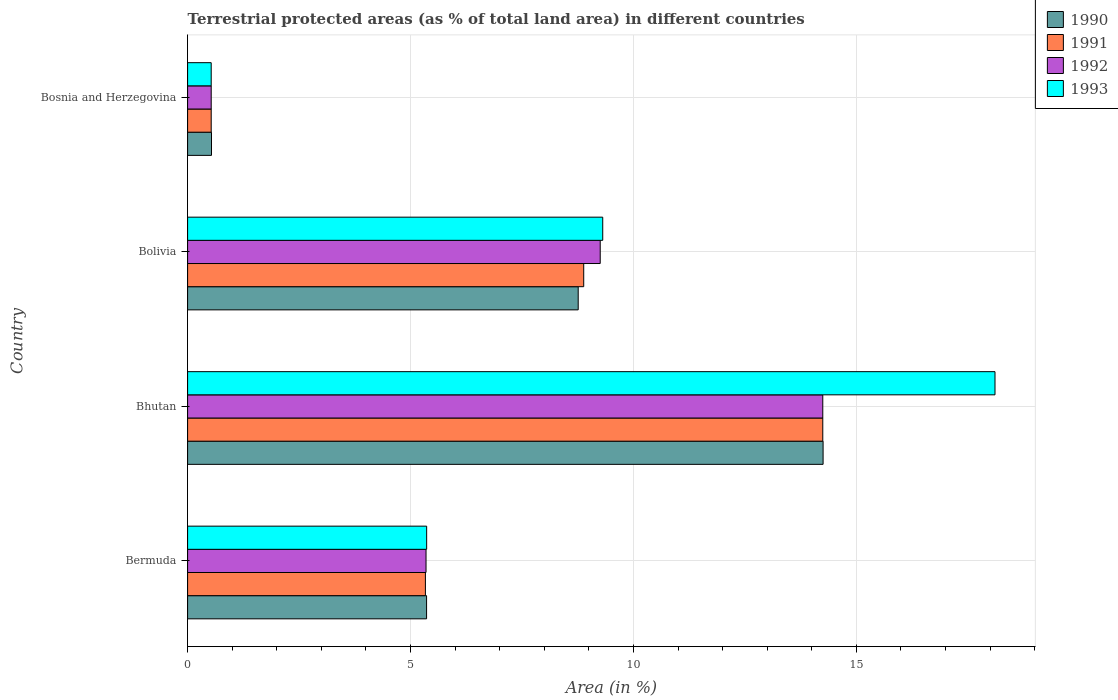How many different coloured bars are there?
Offer a terse response. 4. How many groups of bars are there?
Give a very brief answer. 4. How many bars are there on the 2nd tick from the top?
Offer a very short reply. 4. How many bars are there on the 3rd tick from the bottom?
Provide a succinct answer. 4. What is the label of the 2nd group of bars from the top?
Offer a very short reply. Bolivia. What is the percentage of terrestrial protected land in 1992 in Bhutan?
Ensure brevity in your answer.  14.25. Across all countries, what is the maximum percentage of terrestrial protected land in 1991?
Your answer should be very brief. 14.25. Across all countries, what is the minimum percentage of terrestrial protected land in 1991?
Offer a terse response. 0.53. In which country was the percentage of terrestrial protected land in 1993 maximum?
Make the answer very short. Bhutan. In which country was the percentage of terrestrial protected land in 1991 minimum?
Provide a succinct answer. Bosnia and Herzegovina. What is the total percentage of terrestrial protected land in 1991 in the graph?
Your answer should be compact. 28.99. What is the difference between the percentage of terrestrial protected land in 1991 in Bolivia and that in Bosnia and Herzegovina?
Your answer should be compact. 8.35. What is the difference between the percentage of terrestrial protected land in 1993 in Bolivia and the percentage of terrestrial protected land in 1991 in Bosnia and Herzegovina?
Your response must be concise. 8.78. What is the average percentage of terrestrial protected land in 1993 per country?
Provide a succinct answer. 8.33. What is the difference between the percentage of terrestrial protected land in 1990 and percentage of terrestrial protected land in 1992 in Bhutan?
Ensure brevity in your answer.  0.01. In how many countries, is the percentage of terrestrial protected land in 1992 greater than 2 %?
Your answer should be compact. 3. What is the ratio of the percentage of terrestrial protected land in 1991 in Bermuda to that in Bhutan?
Ensure brevity in your answer.  0.37. What is the difference between the highest and the second highest percentage of terrestrial protected land in 1991?
Give a very brief answer. 5.36. What is the difference between the highest and the lowest percentage of terrestrial protected land in 1990?
Ensure brevity in your answer.  13.72. Is the sum of the percentage of terrestrial protected land in 1991 in Bermuda and Bosnia and Herzegovina greater than the maximum percentage of terrestrial protected land in 1992 across all countries?
Your answer should be compact. No. What does the 2nd bar from the top in Bermuda represents?
Your answer should be compact. 1992. What does the 4th bar from the bottom in Bermuda represents?
Offer a terse response. 1993. Are all the bars in the graph horizontal?
Keep it short and to the point. Yes. How many countries are there in the graph?
Give a very brief answer. 4. What is the difference between two consecutive major ticks on the X-axis?
Provide a short and direct response. 5. Are the values on the major ticks of X-axis written in scientific E-notation?
Provide a succinct answer. No. Does the graph contain grids?
Offer a very short reply. Yes. Where does the legend appear in the graph?
Keep it short and to the point. Top right. How many legend labels are there?
Make the answer very short. 4. How are the legend labels stacked?
Provide a succinct answer. Vertical. What is the title of the graph?
Your answer should be very brief. Terrestrial protected areas (as % of total land area) in different countries. Does "1997" appear as one of the legend labels in the graph?
Provide a short and direct response. No. What is the label or title of the X-axis?
Keep it short and to the point. Area (in %). What is the Area (in %) in 1990 in Bermuda?
Keep it short and to the point. 5.36. What is the Area (in %) in 1991 in Bermuda?
Provide a short and direct response. 5.33. What is the Area (in %) in 1992 in Bermuda?
Keep it short and to the point. 5.35. What is the Area (in %) of 1993 in Bermuda?
Offer a very short reply. 5.36. What is the Area (in %) in 1990 in Bhutan?
Your answer should be very brief. 14.25. What is the Area (in %) of 1991 in Bhutan?
Offer a terse response. 14.25. What is the Area (in %) in 1992 in Bhutan?
Offer a terse response. 14.25. What is the Area (in %) in 1993 in Bhutan?
Offer a very short reply. 18.11. What is the Area (in %) in 1990 in Bolivia?
Your response must be concise. 8.76. What is the Area (in %) of 1991 in Bolivia?
Offer a terse response. 8.88. What is the Area (in %) of 1992 in Bolivia?
Provide a short and direct response. 9.25. What is the Area (in %) in 1993 in Bolivia?
Provide a short and direct response. 9.31. What is the Area (in %) in 1990 in Bosnia and Herzegovina?
Your answer should be very brief. 0.54. What is the Area (in %) in 1991 in Bosnia and Herzegovina?
Your answer should be very brief. 0.53. What is the Area (in %) in 1992 in Bosnia and Herzegovina?
Your response must be concise. 0.53. What is the Area (in %) in 1993 in Bosnia and Herzegovina?
Keep it short and to the point. 0.53. Across all countries, what is the maximum Area (in %) of 1990?
Provide a succinct answer. 14.25. Across all countries, what is the maximum Area (in %) in 1991?
Provide a short and direct response. 14.25. Across all countries, what is the maximum Area (in %) in 1992?
Your answer should be very brief. 14.25. Across all countries, what is the maximum Area (in %) in 1993?
Your answer should be very brief. 18.11. Across all countries, what is the minimum Area (in %) in 1990?
Keep it short and to the point. 0.54. Across all countries, what is the minimum Area (in %) of 1991?
Provide a succinct answer. 0.53. Across all countries, what is the minimum Area (in %) in 1992?
Ensure brevity in your answer.  0.53. Across all countries, what is the minimum Area (in %) in 1993?
Provide a short and direct response. 0.53. What is the total Area (in %) of 1990 in the graph?
Keep it short and to the point. 28.91. What is the total Area (in %) in 1991 in the graph?
Ensure brevity in your answer.  28.99. What is the total Area (in %) in 1992 in the graph?
Your answer should be very brief. 29.38. What is the total Area (in %) of 1993 in the graph?
Give a very brief answer. 33.31. What is the difference between the Area (in %) of 1990 in Bermuda and that in Bhutan?
Your answer should be very brief. -8.89. What is the difference between the Area (in %) in 1991 in Bermuda and that in Bhutan?
Offer a terse response. -8.91. What is the difference between the Area (in %) of 1992 in Bermuda and that in Bhutan?
Make the answer very short. -8.9. What is the difference between the Area (in %) of 1993 in Bermuda and that in Bhutan?
Offer a terse response. -12.75. What is the difference between the Area (in %) of 1990 in Bermuda and that in Bolivia?
Your response must be concise. -3.4. What is the difference between the Area (in %) in 1991 in Bermuda and that in Bolivia?
Provide a succinct answer. -3.55. What is the difference between the Area (in %) in 1992 in Bermuda and that in Bolivia?
Your answer should be very brief. -3.91. What is the difference between the Area (in %) of 1993 in Bermuda and that in Bolivia?
Your answer should be compact. -3.95. What is the difference between the Area (in %) in 1990 in Bermuda and that in Bosnia and Herzegovina?
Offer a very short reply. 4.82. What is the difference between the Area (in %) of 1991 in Bermuda and that in Bosnia and Herzegovina?
Give a very brief answer. 4.8. What is the difference between the Area (in %) in 1992 in Bermuda and that in Bosnia and Herzegovina?
Keep it short and to the point. 4.82. What is the difference between the Area (in %) of 1993 in Bermuda and that in Bosnia and Herzegovina?
Your answer should be very brief. 4.83. What is the difference between the Area (in %) in 1990 in Bhutan and that in Bolivia?
Your answer should be compact. 5.49. What is the difference between the Area (in %) in 1991 in Bhutan and that in Bolivia?
Ensure brevity in your answer.  5.36. What is the difference between the Area (in %) in 1992 in Bhutan and that in Bolivia?
Provide a short and direct response. 4.99. What is the difference between the Area (in %) of 1993 in Bhutan and that in Bolivia?
Provide a short and direct response. 8.8. What is the difference between the Area (in %) of 1990 in Bhutan and that in Bosnia and Herzegovina?
Keep it short and to the point. 13.72. What is the difference between the Area (in %) of 1991 in Bhutan and that in Bosnia and Herzegovina?
Keep it short and to the point. 13.72. What is the difference between the Area (in %) of 1992 in Bhutan and that in Bosnia and Herzegovina?
Ensure brevity in your answer.  13.72. What is the difference between the Area (in %) in 1993 in Bhutan and that in Bosnia and Herzegovina?
Give a very brief answer. 17.58. What is the difference between the Area (in %) of 1990 in Bolivia and that in Bosnia and Herzegovina?
Ensure brevity in your answer.  8.22. What is the difference between the Area (in %) of 1991 in Bolivia and that in Bosnia and Herzegovina?
Give a very brief answer. 8.35. What is the difference between the Area (in %) of 1992 in Bolivia and that in Bosnia and Herzegovina?
Ensure brevity in your answer.  8.72. What is the difference between the Area (in %) of 1993 in Bolivia and that in Bosnia and Herzegovina?
Provide a short and direct response. 8.78. What is the difference between the Area (in %) in 1990 in Bermuda and the Area (in %) in 1991 in Bhutan?
Make the answer very short. -8.89. What is the difference between the Area (in %) in 1990 in Bermuda and the Area (in %) in 1992 in Bhutan?
Your answer should be compact. -8.89. What is the difference between the Area (in %) of 1990 in Bermuda and the Area (in %) of 1993 in Bhutan?
Provide a short and direct response. -12.75. What is the difference between the Area (in %) in 1991 in Bermuda and the Area (in %) in 1992 in Bhutan?
Make the answer very short. -8.91. What is the difference between the Area (in %) of 1991 in Bermuda and the Area (in %) of 1993 in Bhutan?
Give a very brief answer. -12.77. What is the difference between the Area (in %) of 1992 in Bermuda and the Area (in %) of 1993 in Bhutan?
Offer a very short reply. -12.76. What is the difference between the Area (in %) of 1990 in Bermuda and the Area (in %) of 1991 in Bolivia?
Give a very brief answer. -3.52. What is the difference between the Area (in %) in 1990 in Bermuda and the Area (in %) in 1992 in Bolivia?
Keep it short and to the point. -3.89. What is the difference between the Area (in %) of 1990 in Bermuda and the Area (in %) of 1993 in Bolivia?
Your response must be concise. -3.95. What is the difference between the Area (in %) in 1991 in Bermuda and the Area (in %) in 1992 in Bolivia?
Your answer should be compact. -3.92. What is the difference between the Area (in %) of 1991 in Bermuda and the Area (in %) of 1993 in Bolivia?
Offer a terse response. -3.98. What is the difference between the Area (in %) in 1992 in Bermuda and the Area (in %) in 1993 in Bolivia?
Your answer should be compact. -3.96. What is the difference between the Area (in %) of 1990 in Bermuda and the Area (in %) of 1991 in Bosnia and Herzegovina?
Make the answer very short. 4.83. What is the difference between the Area (in %) of 1990 in Bermuda and the Area (in %) of 1992 in Bosnia and Herzegovina?
Ensure brevity in your answer.  4.83. What is the difference between the Area (in %) in 1990 in Bermuda and the Area (in %) in 1993 in Bosnia and Herzegovina?
Give a very brief answer. 4.83. What is the difference between the Area (in %) of 1991 in Bermuda and the Area (in %) of 1992 in Bosnia and Herzegovina?
Offer a very short reply. 4.8. What is the difference between the Area (in %) of 1991 in Bermuda and the Area (in %) of 1993 in Bosnia and Herzegovina?
Your answer should be very brief. 4.8. What is the difference between the Area (in %) of 1992 in Bermuda and the Area (in %) of 1993 in Bosnia and Herzegovina?
Give a very brief answer. 4.82. What is the difference between the Area (in %) in 1990 in Bhutan and the Area (in %) in 1991 in Bolivia?
Offer a very short reply. 5.37. What is the difference between the Area (in %) in 1990 in Bhutan and the Area (in %) in 1992 in Bolivia?
Your answer should be very brief. 5. What is the difference between the Area (in %) in 1990 in Bhutan and the Area (in %) in 1993 in Bolivia?
Provide a succinct answer. 4.94. What is the difference between the Area (in %) in 1991 in Bhutan and the Area (in %) in 1992 in Bolivia?
Your response must be concise. 4.99. What is the difference between the Area (in %) in 1991 in Bhutan and the Area (in %) in 1993 in Bolivia?
Provide a succinct answer. 4.94. What is the difference between the Area (in %) in 1992 in Bhutan and the Area (in %) in 1993 in Bolivia?
Ensure brevity in your answer.  4.94. What is the difference between the Area (in %) of 1990 in Bhutan and the Area (in %) of 1991 in Bosnia and Herzegovina?
Provide a succinct answer. 13.72. What is the difference between the Area (in %) of 1990 in Bhutan and the Area (in %) of 1992 in Bosnia and Herzegovina?
Provide a short and direct response. 13.72. What is the difference between the Area (in %) of 1990 in Bhutan and the Area (in %) of 1993 in Bosnia and Herzegovina?
Offer a very short reply. 13.72. What is the difference between the Area (in %) of 1991 in Bhutan and the Area (in %) of 1992 in Bosnia and Herzegovina?
Your response must be concise. 13.72. What is the difference between the Area (in %) in 1991 in Bhutan and the Area (in %) in 1993 in Bosnia and Herzegovina?
Provide a short and direct response. 13.72. What is the difference between the Area (in %) of 1992 in Bhutan and the Area (in %) of 1993 in Bosnia and Herzegovina?
Your response must be concise. 13.72. What is the difference between the Area (in %) in 1990 in Bolivia and the Area (in %) in 1991 in Bosnia and Herzegovina?
Your answer should be very brief. 8.23. What is the difference between the Area (in %) in 1990 in Bolivia and the Area (in %) in 1992 in Bosnia and Herzegovina?
Your response must be concise. 8.23. What is the difference between the Area (in %) in 1990 in Bolivia and the Area (in %) in 1993 in Bosnia and Herzegovina?
Make the answer very short. 8.23. What is the difference between the Area (in %) in 1991 in Bolivia and the Area (in %) in 1992 in Bosnia and Herzegovina?
Offer a very short reply. 8.35. What is the difference between the Area (in %) of 1991 in Bolivia and the Area (in %) of 1993 in Bosnia and Herzegovina?
Offer a terse response. 8.35. What is the difference between the Area (in %) of 1992 in Bolivia and the Area (in %) of 1993 in Bosnia and Herzegovina?
Make the answer very short. 8.72. What is the average Area (in %) of 1990 per country?
Make the answer very short. 7.23. What is the average Area (in %) in 1991 per country?
Your answer should be compact. 7.25. What is the average Area (in %) in 1992 per country?
Ensure brevity in your answer.  7.34. What is the average Area (in %) in 1993 per country?
Your answer should be compact. 8.33. What is the difference between the Area (in %) of 1990 and Area (in %) of 1991 in Bermuda?
Offer a terse response. 0.03. What is the difference between the Area (in %) in 1990 and Area (in %) in 1992 in Bermuda?
Provide a succinct answer. 0.01. What is the difference between the Area (in %) of 1990 and Area (in %) of 1993 in Bermuda?
Provide a succinct answer. -0. What is the difference between the Area (in %) in 1991 and Area (in %) in 1992 in Bermuda?
Keep it short and to the point. -0.01. What is the difference between the Area (in %) of 1991 and Area (in %) of 1993 in Bermuda?
Provide a short and direct response. -0.03. What is the difference between the Area (in %) of 1992 and Area (in %) of 1993 in Bermuda?
Your answer should be compact. -0.01. What is the difference between the Area (in %) of 1990 and Area (in %) of 1991 in Bhutan?
Keep it short and to the point. 0.01. What is the difference between the Area (in %) in 1990 and Area (in %) in 1992 in Bhutan?
Your answer should be compact. 0.01. What is the difference between the Area (in %) in 1990 and Area (in %) in 1993 in Bhutan?
Your response must be concise. -3.86. What is the difference between the Area (in %) in 1991 and Area (in %) in 1993 in Bhutan?
Keep it short and to the point. -3.86. What is the difference between the Area (in %) in 1992 and Area (in %) in 1993 in Bhutan?
Offer a very short reply. -3.86. What is the difference between the Area (in %) of 1990 and Area (in %) of 1991 in Bolivia?
Your answer should be compact. -0.12. What is the difference between the Area (in %) in 1990 and Area (in %) in 1992 in Bolivia?
Give a very brief answer. -0.49. What is the difference between the Area (in %) of 1990 and Area (in %) of 1993 in Bolivia?
Your answer should be very brief. -0.55. What is the difference between the Area (in %) of 1991 and Area (in %) of 1992 in Bolivia?
Offer a terse response. -0.37. What is the difference between the Area (in %) of 1991 and Area (in %) of 1993 in Bolivia?
Make the answer very short. -0.43. What is the difference between the Area (in %) of 1992 and Area (in %) of 1993 in Bolivia?
Offer a very short reply. -0.06. What is the difference between the Area (in %) in 1990 and Area (in %) in 1991 in Bosnia and Herzegovina?
Your response must be concise. 0.01. What is the difference between the Area (in %) of 1990 and Area (in %) of 1992 in Bosnia and Herzegovina?
Your answer should be compact. 0.01. What is the difference between the Area (in %) in 1990 and Area (in %) in 1993 in Bosnia and Herzegovina?
Your answer should be very brief. 0.01. What is the difference between the Area (in %) of 1991 and Area (in %) of 1993 in Bosnia and Herzegovina?
Your answer should be very brief. 0. What is the difference between the Area (in %) in 1992 and Area (in %) in 1993 in Bosnia and Herzegovina?
Offer a very short reply. 0. What is the ratio of the Area (in %) in 1990 in Bermuda to that in Bhutan?
Your answer should be very brief. 0.38. What is the ratio of the Area (in %) of 1991 in Bermuda to that in Bhutan?
Your answer should be very brief. 0.37. What is the ratio of the Area (in %) of 1992 in Bermuda to that in Bhutan?
Offer a very short reply. 0.38. What is the ratio of the Area (in %) in 1993 in Bermuda to that in Bhutan?
Provide a succinct answer. 0.3. What is the ratio of the Area (in %) of 1990 in Bermuda to that in Bolivia?
Offer a very short reply. 0.61. What is the ratio of the Area (in %) in 1991 in Bermuda to that in Bolivia?
Your response must be concise. 0.6. What is the ratio of the Area (in %) in 1992 in Bermuda to that in Bolivia?
Keep it short and to the point. 0.58. What is the ratio of the Area (in %) in 1993 in Bermuda to that in Bolivia?
Provide a short and direct response. 0.58. What is the ratio of the Area (in %) in 1990 in Bermuda to that in Bosnia and Herzegovina?
Your response must be concise. 10. What is the ratio of the Area (in %) of 1991 in Bermuda to that in Bosnia and Herzegovina?
Provide a succinct answer. 10.07. What is the ratio of the Area (in %) of 1992 in Bermuda to that in Bosnia and Herzegovina?
Ensure brevity in your answer.  10.1. What is the ratio of the Area (in %) in 1993 in Bermuda to that in Bosnia and Herzegovina?
Offer a very short reply. 10.13. What is the ratio of the Area (in %) of 1990 in Bhutan to that in Bolivia?
Provide a short and direct response. 1.63. What is the ratio of the Area (in %) in 1991 in Bhutan to that in Bolivia?
Make the answer very short. 1.6. What is the ratio of the Area (in %) of 1992 in Bhutan to that in Bolivia?
Keep it short and to the point. 1.54. What is the ratio of the Area (in %) in 1993 in Bhutan to that in Bolivia?
Your answer should be very brief. 1.94. What is the ratio of the Area (in %) of 1990 in Bhutan to that in Bosnia and Herzegovina?
Your response must be concise. 26.59. What is the ratio of the Area (in %) in 1991 in Bhutan to that in Bosnia and Herzegovina?
Give a very brief answer. 26.9. What is the ratio of the Area (in %) of 1992 in Bhutan to that in Bosnia and Herzegovina?
Your answer should be compact. 26.9. What is the ratio of the Area (in %) in 1993 in Bhutan to that in Bosnia and Herzegovina?
Your response must be concise. 34.2. What is the ratio of the Area (in %) of 1990 in Bolivia to that in Bosnia and Herzegovina?
Your answer should be very brief. 16.34. What is the ratio of the Area (in %) in 1991 in Bolivia to that in Bosnia and Herzegovina?
Your answer should be compact. 16.78. What is the ratio of the Area (in %) in 1992 in Bolivia to that in Bosnia and Herzegovina?
Keep it short and to the point. 17.48. What is the ratio of the Area (in %) of 1993 in Bolivia to that in Bosnia and Herzegovina?
Your response must be concise. 17.58. What is the difference between the highest and the second highest Area (in %) in 1990?
Provide a short and direct response. 5.49. What is the difference between the highest and the second highest Area (in %) in 1991?
Your response must be concise. 5.36. What is the difference between the highest and the second highest Area (in %) in 1992?
Ensure brevity in your answer.  4.99. What is the difference between the highest and the second highest Area (in %) in 1993?
Provide a short and direct response. 8.8. What is the difference between the highest and the lowest Area (in %) of 1990?
Your response must be concise. 13.72. What is the difference between the highest and the lowest Area (in %) in 1991?
Give a very brief answer. 13.72. What is the difference between the highest and the lowest Area (in %) in 1992?
Offer a terse response. 13.72. What is the difference between the highest and the lowest Area (in %) in 1993?
Your answer should be compact. 17.58. 